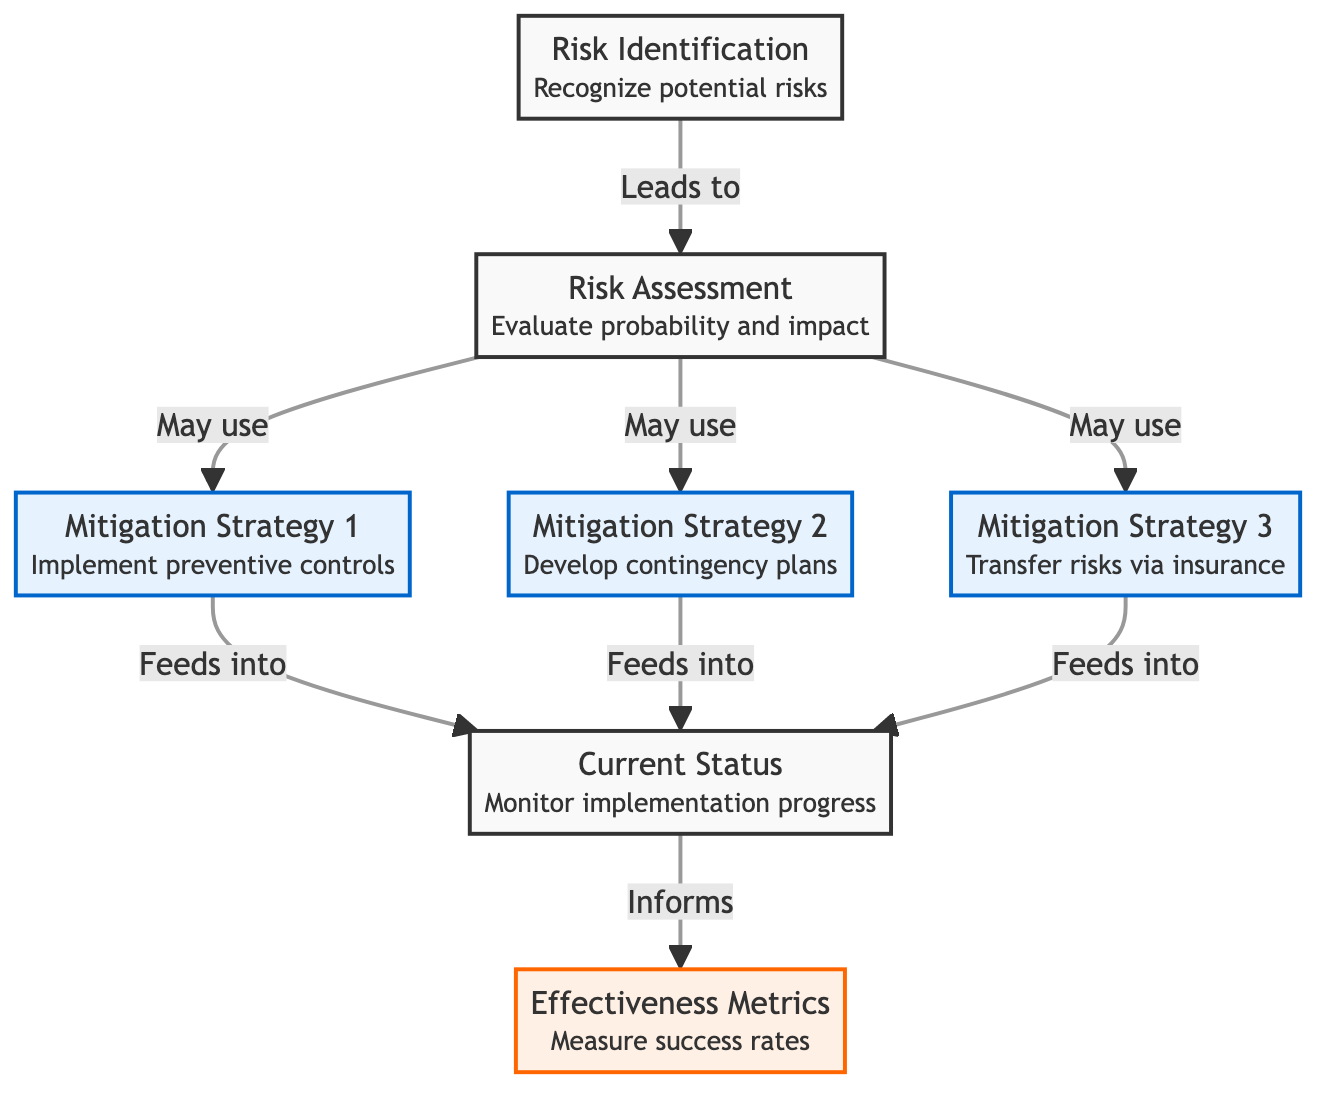What does the first node of the diagram represent? The first node labeled "Risk Identification" describes the process of recognizing potential risks. It is the initial step that leads to subsequent analysis stages in the risk management process.
Answer: Risk Identification How many mitigation strategies are identified in the diagram? There are three mitigation strategies indicated in the diagram, each designated as a separate node. This quantification comes directly from counting the nodes labeled for mitigation strategies.
Answer: 3 Which node feeds into the "Current Status"? The three mitigation strategies ("Mitigation Strategy 1," "Mitigation Strategy 2," and "Mitigation Strategy 3") all feed into the "Current Status," reflecting their contributions to monitoring the implementation of these strategies.
Answer: Mitigation Strategy 1, Mitigation Strategy 2, Mitigation Strategy 3 What is the role of the node labeled "Effectiveness Metrics"? The "Effectiveness Metrics" node receives information from the "Current Status" node, indicating that it measures success rates based on the status of implemented mitigation strategies.
Answer: Measure success rates What relationship exists between "Risk Assessment" and the mitigation strategies? The relationship is that "Risk Assessment" may employ or utilize the various mitigation strategies as potential solutions for the risks identified. Each strategy connects back to the assessment process for potentially using them.
Answer: May use How many total nodes are there in this diagram? There are seven distinct nodes in the diagram, comprising two nodes for risk processes, three for mitigation strategies, and two for status and metrics. This total is determined by counting each unique labeled node shown.
Answer: 7 What does the "Current Status" inform? The "Current Status" node informs the "Effectiveness Metrics," indicating that it provides the data necessary for measuring the success rates of the strategies implemented.
Answer: Effectiveness Metrics What type of control is referenced in "Mitigation Strategy 1"? "Mitigation Strategy 1" refers to "Implement preventive controls," indicating a proactive approach to managing risks before they occur.
Answer: Preventive controls Which stage in the diagram directly follows "Risk Assessment"? After "Risk Assessment," the process can lead directly to employing one or more of the mitigation strategies, which involve developing specific actions to address the assessed risks.
Answer: Mitigation Strategies 